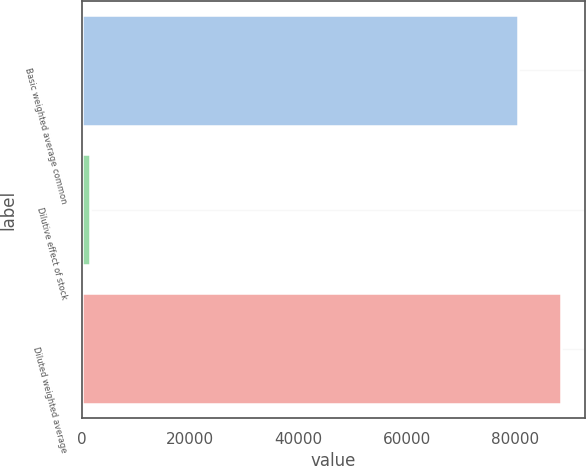Convert chart to OTSL. <chart><loc_0><loc_0><loc_500><loc_500><bar_chart><fcel>Basic weighted average common<fcel>Dilutive effect of stock<fcel>Diluted weighted average<nl><fcel>80466<fcel>1517<fcel>88512.6<nl></chart> 